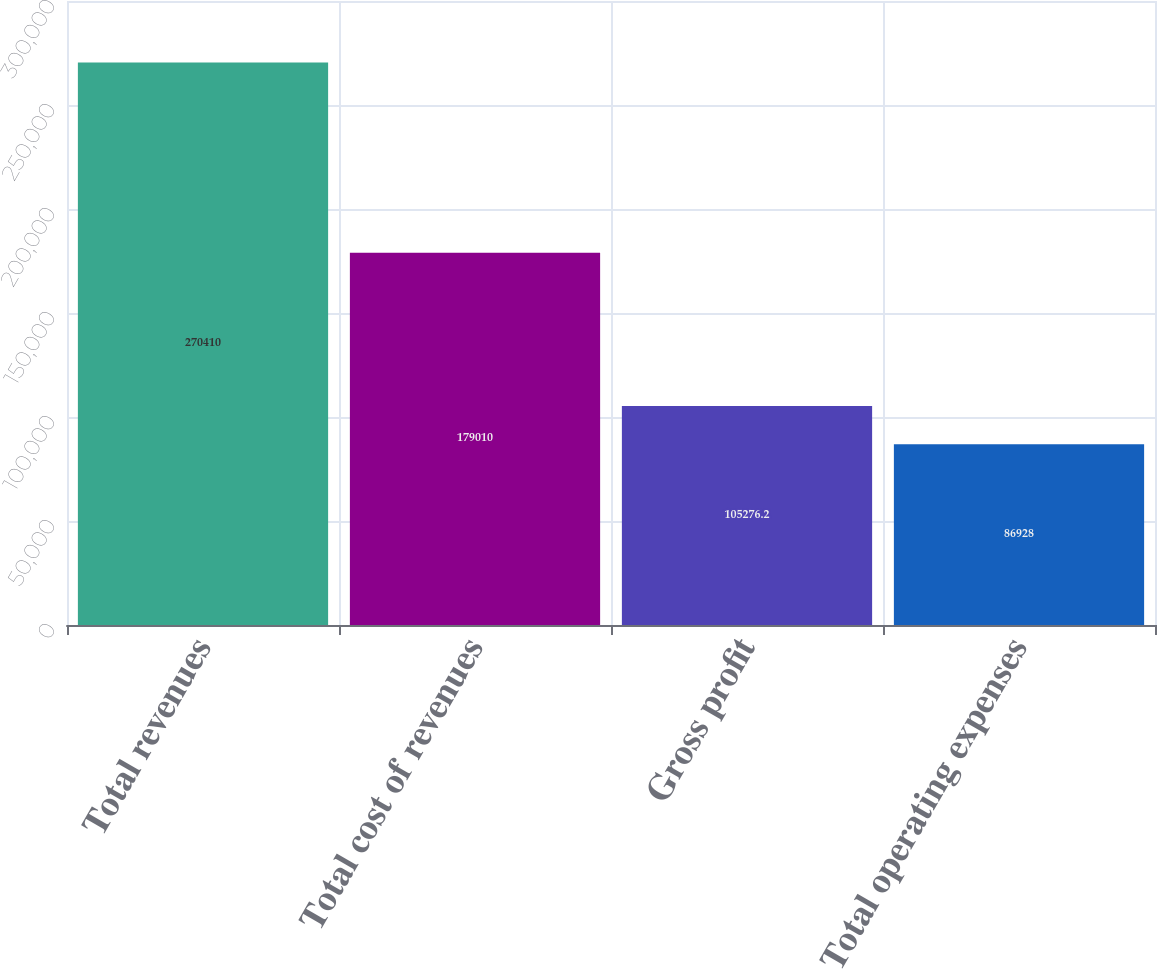<chart> <loc_0><loc_0><loc_500><loc_500><bar_chart><fcel>Total revenues<fcel>Total cost of revenues<fcel>Gross profit<fcel>Total operating expenses<nl><fcel>270410<fcel>179010<fcel>105276<fcel>86928<nl></chart> 